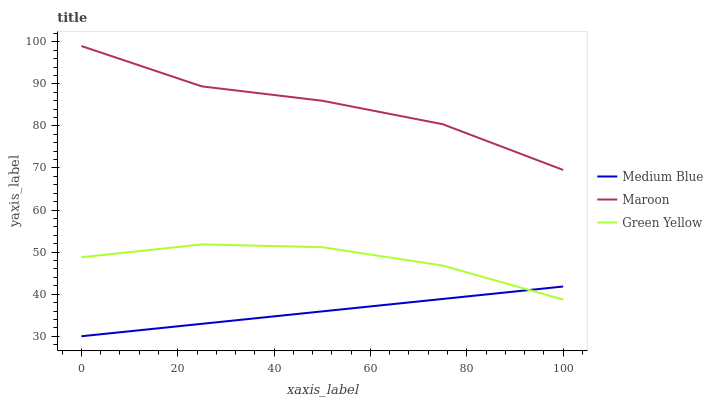Does Medium Blue have the minimum area under the curve?
Answer yes or no. Yes. Does Maroon have the maximum area under the curve?
Answer yes or no. Yes. Does Maroon have the minimum area under the curve?
Answer yes or no. No. Does Medium Blue have the maximum area under the curve?
Answer yes or no. No. Is Medium Blue the smoothest?
Answer yes or no. Yes. Is Maroon the roughest?
Answer yes or no. Yes. Is Maroon the smoothest?
Answer yes or no. No. Is Medium Blue the roughest?
Answer yes or no. No. Does Maroon have the lowest value?
Answer yes or no. No. Does Medium Blue have the highest value?
Answer yes or no. No. Is Green Yellow less than Maroon?
Answer yes or no. Yes. Is Maroon greater than Green Yellow?
Answer yes or no. Yes. Does Green Yellow intersect Maroon?
Answer yes or no. No. 